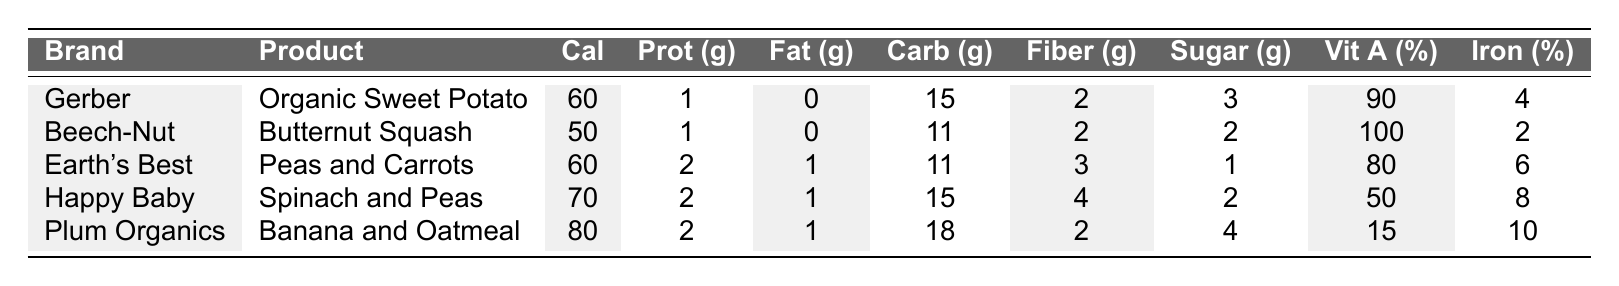What is the calorie count for Earth's Best Peas and Carrots? According to the table, Earth's Best Peas and Carrots has a calorie count of 60.
Answer: 60 Which brand has the highest vitamin A percentage? The highest vitamin A percentage in the table is 100%, which belongs to Beech-Nut Butternut Squash.
Answer: Beech-Nut Is there any product that contains zero fat? Gerber Organic Sweet Potato and Beech-Nut Butternut Squash both have zero fat, as indicated in the table.
Answer: Yes What is the average sugar content across all brands? Adding the sugar content for all brands gives (3 + 2 + 1 + 2 + 4) = 12 grams. Dividing by 5 brands gives an average of 12/5 = 2.4 grams of sugar.
Answer: 2.4 Which product has the lowest iron percentage? By checking the iron percentage, Beech-Nut Butternut Squash has the lowest iron percentage at 2%.
Answer: 2% How much more carbohydrates does Plum Organics have compared to Beech-Nut? Plum Organics has 18 grams of carbohydrates and Beech-Nut has 11 grams. The difference is 18 - 11 = 7 grams.
Answer: 7 grams Does Happy Baby Spinach and Peas contain more fiber than Gerber Organic Sweet Potato? Happy Baby has 4 grams of fiber while Gerber has 2 grams. Therefore, Happy Baby contains more fiber.
Answer: Yes Which product has the highest protein content? The table shows Earth's Best Peas and Carrots, Happy Baby Spinach and Peas, and Plum Organics Banana and Oatmeal each have the highest protein content of 2 grams.
Answer: 2 grams What is the total calorie content of all products combined? The total calorie content is calculated by summing the calories: 60 + 50 + 60 + 70 + 80 = 320 calories.
Answer: 320 calories Which brand has the lowest sugar content? The lowest sugar content is 1 gram found in Earth's Best Peas and Carrots.
Answer: Earth's Best 